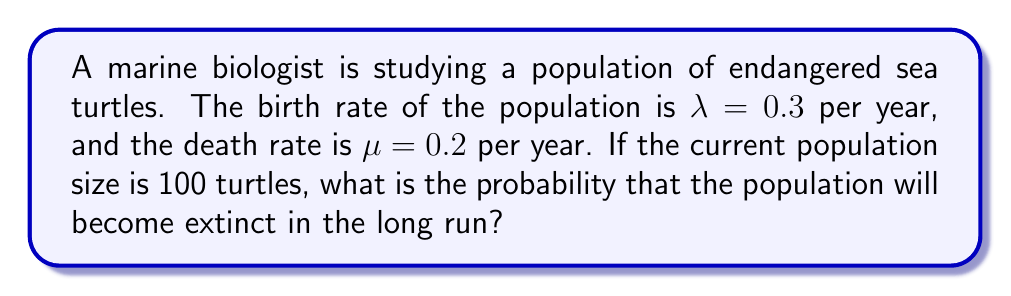Solve this math problem. To solve this problem, we'll use the concept of birth-death processes in the context of population dynamics:

1) In a birth-death process, the probability of eventual extinction, denoted as $q$, is given by the equation:

   $q = \min(1, (\frac{\mu}{\lambda})^1)$

   where $\lambda$ is the birth rate and $\mu$ is the death rate.

2) We're given:
   $\lambda = 0.3$ (birth rate)
   $\mu = 0.2$ (death rate)

3) Let's calculate $\frac{\mu}{\lambda}$:

   $\frac{\mu}{\lambda} = \frac{0.2}{0.3} \approx 0.6667$

4) Since $\frac{\mu}{\lambda} < 1$, the probability of extinction is equal to $(\frac{\mu}{\lambda})^1$:

   $q = (\frac{0.2}{0.3})^1 \approx 0.6667$

5) Therefore, the probability of eventual extinction is approximately 0.6667 or about 66.67%.

This result suggests that despite the current population of 100 turtles, there's a significant risk of extinction in the long run, highlighting the importance of conservation efforts for this endangered species.
Answer: $\frac{2}{3}$ or approximately 0.6667 